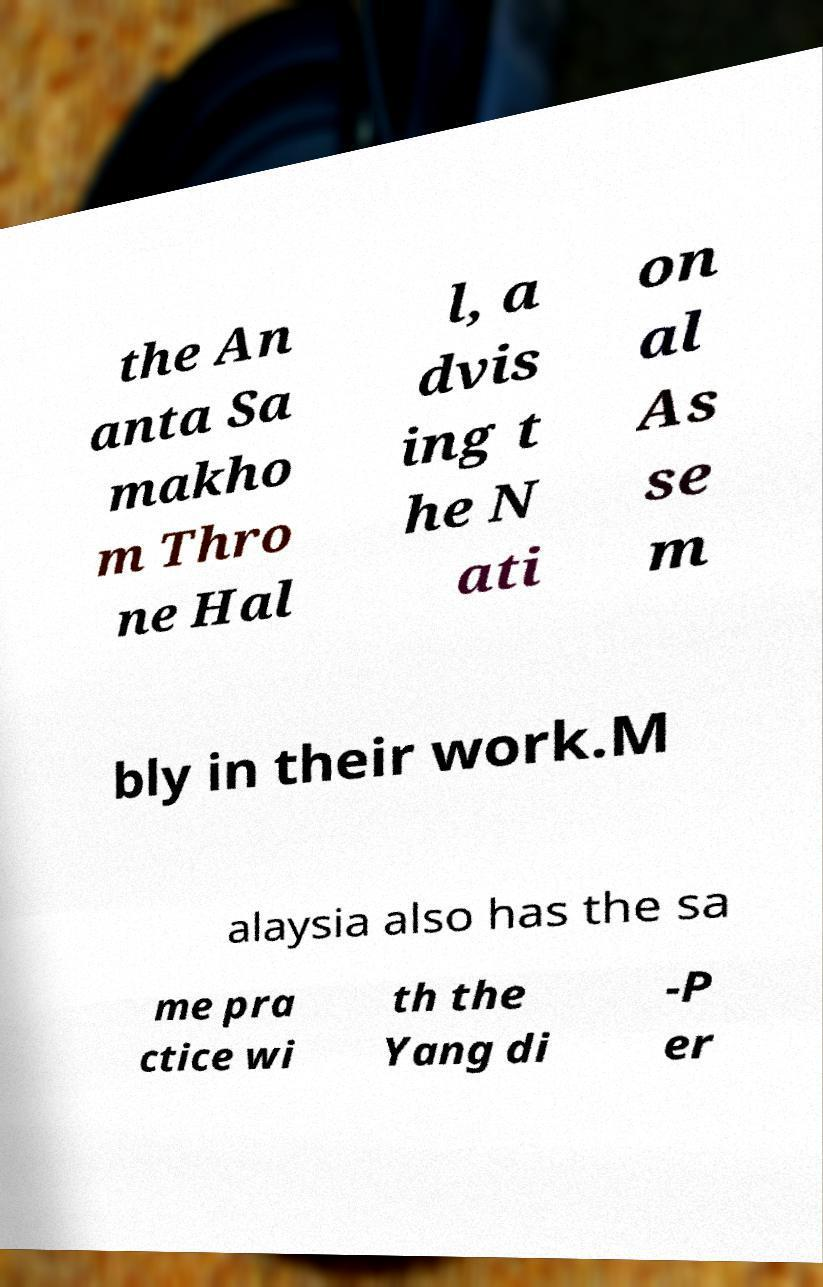What messages or text are displayed in this image? I need them in a readable, typed format. the An anta Sa makho m Thro ne Hal l, a dvis ing t he N ati on al As se m bly in their work.M alaysia also has the sa me pra ctice wi th the Yang di -P er 